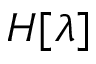Convert formula to latex. <formula><loc_0><loc_0><loc_500><loc_500>H [ \lambda ]</formula> 